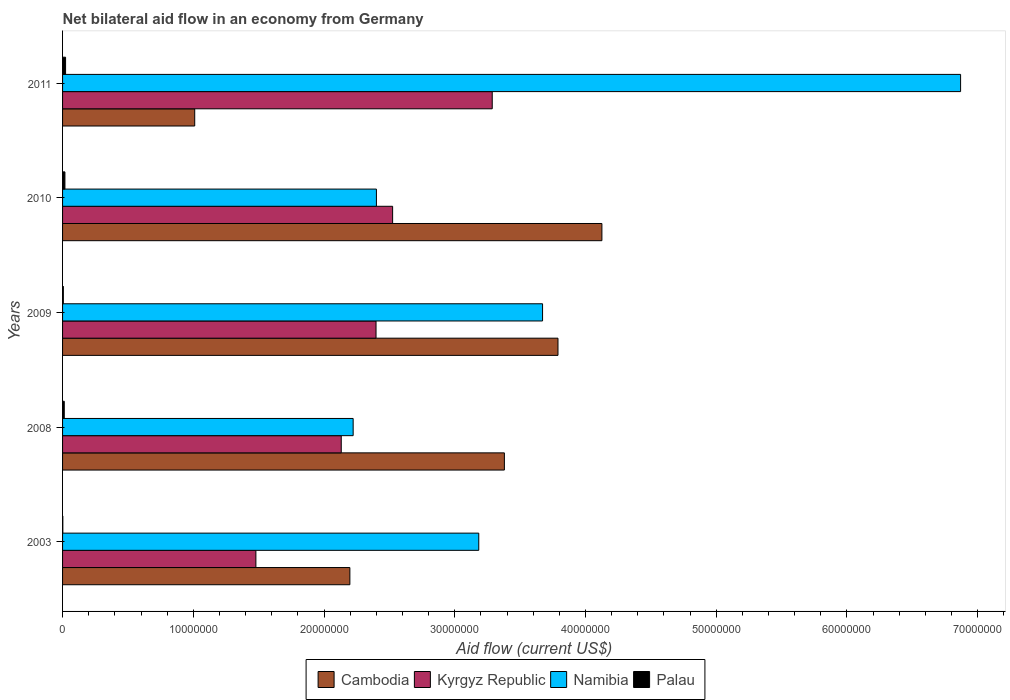How many different coloured bars are there?
Your answer should be compact. 4. How many groups of bars are there?
Offer a terse response. 5. Are the number of bars on each tick of the Y-axis equal?
Provide a short and direct response. Yes. How many bars are there on the 1st tick from the bottom?
Your answer should be very brief. 4. What is the net bilateral aid flow in Namibia in 2008?
Offer a terse response. 2.22e+07. Across all years, what is the maximum net bilateral aid flow in Namibia?
Give a very brief answer. 6.87e+07. Across all years, what is the minimum net bilateral aid flow in Kyrgyz Republic?
Offer a very short reply. 1.48e+07. In which year was the net bilateral aid flow in Kyrgyz Republic maximum?
Keep it short and to the point. 2011. In which year was the net bilateral aid flow in Palau minimum?
Provide a succinct answer. 2003. What is the total net bilateral aid flow in Kyrgyz Republic in the graph?
Give a very brief answer. 1.18e+08. What is the difference between the net bilateral aid flow in Palau in 2008 and that in 2011?
Offer a very short reply. -1.00e+05. What is the difference between the net bilateral aid flow in Kyrgyz Republic in 2010 and the net bilateral aid flow in Cambodia in 2003?
Your answer should be very brief. 3.27e+06. What is the average net bilateral aid flow in Namibia per year?
Provide a short and direct response. 3.67e+07. In the year 2009, what is the difference between the net bilateral aid flow in Namibia and net bilateral aid flow in Kyrgyz Republic?
Ensure brevity in your answer.  1.27e+07. In how many years, is the net bilateral aid flow in Cambodia greater than 40000000 US$?
Your answer should be compact. 1. What is the ratio of the net bilateral aid flow in Palau in 2003 to that in 2009?
Your answer should be compact. 0.33. What is the difference between the highest and the second highest net bilateral aid flow in Kyrgyz Republic?
Offer a terse response. 7.62e+06. What is the difference between the highest and the lowest net bilateral aid flow in Cambodia?
Give a very brief answer. 3.12e+07. In how many years, is the net bilateral aid flow in Kyrgyz Republic greater than the average net bilateral aid flow in Kyrgyz Republic taken over all years?
Your response must be concise. 3. Is the sum of the net bilateral aid flow in Namibia in 2009 and 2010 greater than the maximum net bilateral aid flow in Kyrgyz Republic across all years?
Ensure brevity in your answer.  Yes. Is it the case that in every year, the sum of the net bilateral aid flow in Cambodia and net bilateral aid flow in Palau is greater than the sum of net bilateral aid flow in Namibia and net bilateral aid flow in Kyrgyz Republic?
Provide a short and direct response. No. What does the 1st bar from the top in 2009 represents?
Your answer should be compact. Palau. What does the 3rd bar from the bottom in 2003 represents?
Provide a succinct answer. Namibia. Are all the bars in the graph horizontal?
Keep it short and to the point. Yes. How many years are there in the graph?
Provide a succinct answer. 5. What is the difference between two consecutive major ticks on the X-axis?
Your response must be concise. 1.00e+07. Are the values on the major ticks of X-axis written in scientific E-notation?
Ensure brevity in your answer.  No. Does the graph contain any zero values?
Offer a very short reply. No. Does the graph contain grids?
Give a very brief answer. No. Where does the legend appear in the graph?
Provide a short and direct response. Bottom center. What is the title of the graph?
Your answer should be compact. Net bilateral aid flow in an economy from Germany. What is the label or title of the Y-axis?
Your response must be concise. Years. What is the Aid flow (current US$) of Cambodia in 2003?
Keep it short and to the point. 2.20e+07. What is the Aid flow (current US$) of Kyrgyz Republic in 2003?
Keep it short and to the point. 1.48e+07. What is the Aid flow (current US$) of Namibia in 2003?
Make the answer very short. 3.18e+07. What is the Aid flow (current US$) of Cambodia in 2008?
Give a very brief answer. 3.38e+07. What is the Aid flow (current US$) in Kyrgyz Republic in 2008?
Your answer should be compact. 2.13e+07. What is the Aid flow (current US$) in Namibia in 2008?
Ensure brevity in your answer.  2.22e+07. What is the Aid flow (current US$) in Palau in 2008?
Your answer should be very brief. 1.30e+05. What is the Aid flow (current US$) in Cambodia in 2009?
Your response must be concise. 3.79e+07. What is the Aid flow (current US$) in Kyrgyz Republic in 2009?
Keep it short and to the point. 2.40e+07. What is the Aid flow (current US$) in Namibia in 2009?
Your response must be concise. 3.67e+07. What is the Aid flow (current US$) in Palau in 2009?
Provide a short and direct response. 6.00e+04. What is the Aid flow (current US$) of Cambodia in 2010?
Provide a succinct answer. 4.13e+07. What is the Aid flow (current US$) of Kyrgyz Republic in 2010?
Ensure brevity in your answer.  2.52e+07. What is the Aid flow (current US$) in Namibia in 2010?
Your response must be concise. 2.40e+07. What is the Aid flow (current US$) of Palau in 2010?
Provide a short and direct response. 1.80e+05. What is the Aid flow (current US$) of Cambodia in 2011?
Your answer should be compact. 1.01e+07. What is the Aid flow (current US$) in Kyrgyz Republic in 2011?
Ensure brevity in your answer.  3.29e+07. What is the Aid flow (current US$) of Namibia in 2011?
Your response must be concise. 6.87e+07. Across all years, what is the maximum Aid flow (current US$) in Cambodia?
Your answer should be very brief. 4.13e+07. Across all years, what is the maximum Aid flow (current US$) in Kyrgyz Republic?
Make the answer very short. 3.29e+07. Across all years, what is the maximum Aid flow (current US$) of Namibia?
Keep it short and to the point. 6.87e+07. Across all years, what is the maximum Aid flow (current US$) of Palau?
Make the answer very short. 2.30e+05. Across all years, what is the minimum Aid flow (current US$) of Cambodia?
Keep it short and to the point. 1.01e+07. Across all years, what is the minimum Aid flow (current US$) in Kyrgyz Republic?
Offer a terse response. 1.48e+07. Across all years, what is the minimum Aid flow (current US$) of Namibia?
Offer a terse response. 2.22e+07. What is the total Aid flow (current US$) of Cambodia in the graph?
Give a very brief answer. 1.45e+08. What is the total Aid flow (current US$) of Kyrgyz Republic in the graph?
Ensure brevity in your answer.  1.18e+08. What is the total Aid flow (current US$) in Namibia in the graph?
Provide a succinct answer. 1.84e+08. What is the total Aid flow (current US$) in Palau in the graph?
Provide a short and direct response. 6.20e+05. What is the difference between the Aid flow (current US$) in Cambodia in 2003 and that in 2008?
Give a very brief answer. -1.18e+07. What is the difference between the Aid flow (current US$) in Kyrgyz Republic in 2003 and that in 2008?
Give a very brief answer. -6.53e+06. What is the difference between the Aid flow (current US$) of Namibia in 2003 and that in 2008?
Keep it short and to the point. 9.61e+06. What is the difference between the Aid flow (current US$) in Palau in 2003 and that in 2008?
Provide a succinct answer. -1.10e+05. What is the difference between the Aid flow (current US$) in Cambodia in 2003 and that in 2009?
Ensure brevity in your answer.  -1.59e+07. What is the difference between the Aid flow (current US$) of Kyrgyz Republic in 2003 and that in 2009?
Offer a very short reply. -9.19e+06. What is the difference between the Aid flow (current US$) of Namibia in 2003 and that in 2009?
Provide a succinct answer. -4.88e+06. What is the difference between the Aid flow (current US$) in Cambodia in 2003 and that in 2010?
Give a very brief answer. -1.93e+07. What is the difference between the Aid flow (current US$) of Kyrgyz Republic in 2003 and that in 2010?
Provide a succinct answer. -1.05e+07. What is the difference between the Aid flow (current US$) in Namibia in 2003 and that in 2010?
Your answer should be compact. 7.83e+06. What is the difference between the Aid flow (current US$) of Palau in 2003 and that in 2010?
Keep it short and to the point. -1.60e+05. What is the difference between the Aid flow (current US$) in Cambodia in 2003 and that in 2011?
Your answer should be very brief. 1.19e+07. What is the difference between the Aid flow (current US$) of Kyrgyz Republic in 2003 and that in 2011?
Offer a very short reply. -1.81e+07. What is the difference between the Aid flow (current US$) in Namibia in 2003 and that in 2011?
Keep it short and to the point. -3.69e+07. What is the difference between the Aid flow (current US$) in Cambodia in 2008 and that in 2009?
Offer a terse response. -4.10e+06. What is the difference between the Aid flow (current US$) in Kyrgyz Republic in 2008 and that in 2009?
Your answer should be compact. -2.66e+06. What is the difference between the Aid flow (current US$) in Namibia in 2008 and that in 2009?
Offer a very short reply. -1.45e+07. What is the difference between the Aid flow (current US$) of Palau in 2008 and that in 2009?
Offer a very short reply. 7.00e+04. What is the difference between the Aid flow (current US$) of Cambodia in 2008 and that in 2010?
Your answer should be compact. -7.46e+06. What is the difference between the Aid flow (current US$) in Kyrgyz Republic in 2008 and that in 2010?
Offer a terse response. -3.93e+06. What is the difference between the Aid flow (current US$) of Namibia in 2008 and that in 2010?
Your answer should be compact. -1.78e+06. What is the difference between the Aid flow (current US$) of Palau in 2008 and that in 2010?
Provide a succinct answer. -5.00e+04. What is the difference between the Aid flow (current US$) in Cambodia in 2008 and that in 2011?
Provide a short and direct response. 2.37e+07. What is the difference between the Aid flow (current US$) of Kyrgyz Republic in 2008 and that in 2011?
Your answer should be very brief. -1.16e+07. What is the difference between the Aid flow (current US$) in Namibia in 2008 and that in 2011?
Your answer should be compact. -4.65e+07. What is the difference between the Aid flow (current US$) in Palau in 2008 and that in 2011?
Your response must be concise. -1.00e+05. What is the difference between the Aid flow (current US$) of Cambodia in 2009 and that in 2010?
Provide a succinct answer. -3.36e+06. What is the difference between the Aid flow (current US$) in Kyrgyz Republic in 2009 and that in 2010?
Give a very brief answer. -1.27e+06. What is the difference between the Aid flow (current US$) of Namibia in 2009 and that in 2010?
Offer a very short reply. 1.27e+07. What is the difference between the Aid flow (current US$) of Cambodia in 2009 and that in 2011?
Provide a short and direct response. 2.78e+07. What is the difference between the Aid flow (current US$) of Kyrgyz Republic in 2009 and that in 2011?
Your response must be concise. -8.89e+06. What is the difference between the Aid flow (current US$) of Namibia in 2009 and that in 2011?
Keep it short and to the point. -3.20e+07. What is the difference between the Aid flow (current US$) in Palau in 2009 and that in 2011?
Ensure brevity in your answer.  -1.70e+05. What is the difference between the Aid flow (current US$) of Cambodia in 2010 and that in 2011?
Provide a succinct answer. 3.12e+07. What is the difference between the Aid flow (current US$) of Kyrgyz Republic in 2010 and that in 2011?
Your answer should be compact. -7.62e+06. What is the difference between the Aid flow (current US$) in Namibia in 2010 and that in 2011?
Your response must be concise. -4.47e+07. What is the difference between the Aid flow (current US$) in Cambodia in 2003 and the Aid flow (current US$) in Kyrgyz Republic in 2008?
Make the answer very short. 6.60e+05. What is the difference between the Aid flow (current US$) of Cambodia in 2003 and the Aid flow (current US$) of Palau in 2008?
Make the answer very short. 2.18e+07. What is the difference between the Aid flow (current US$) in Kyrgyz Republic in 2003 and the Aid flow (current US$) in Namibia in 2008?
Provide a short and direct response. -7.44e+06. What is the difference between the Aid flow (current US$) of Kyrgyz Republic in 2003 and the Aid flow (current US$) of Palau in 2008?
Provide a succinct answer. 1.47e+07. What is the difference between the Aid flow (current US$) of Namibia in 2003 and the Aid flow (current US$) of Palau in 2008?
Ensure brevity in your answer.  3.17e+07. What is the difference between the Aid flow (current US$) in Cambodia in 2003 and the Aid flow (current US$) in Namibia in 2009?
Offer a terse response. -1.47e+07. What is the difference between the Aid flow (current US$) in Cambodia in 2003 and the Aid flow (current US$) in Palau in 2009?
Ensure brevity in your answer.  2.19e+07. What is the difference between the Aid flow (current US$) in Kyrgyz Republic in 2003 and the Aid flow (current US$) in Namibia in 2009?
Provide a short and direct response. -2.19e+07. What is the difference between the Aid flow (current US$) in Kyrgyz Republic in 2003 and the Aid flow (current US$) in Palau in 2009?
Provide a succinct answer. 1.47e+07. What is the difference between the Aid flow (current US$) of Namibia in 2003 and the Aid flow (current US$) of Palau in 2009?
Your response must be concise. 3.18e+07. What is the difference between the Aid flow (current US$) of Cambodia in 2003 and the Aid flow (current US$) of Kyrgyz Republic in 2010?
Offer a terse response. -3.27e+06. What is the difference between the Aid flow (current US$) in Cambodia in 2003 and the Aid flow (current US$) in Namibia in 2010?
Offer a very short reply. -2.03e+06. What is the difference between the Aid flow (current US$) of Cambodia in 2003 and the Aid flow (current US$) of Palau in 2010?
Make the answer very short. 2.18e+07. What is the difference between the Aid flow (current US$) of Kyrgyz Republic in 2003 and the Aid flow (current US$) of Namibia in 2010?
Ensure brevity in your answer.  -9.22e+06. What is the difference between the Aid flow (current US$) in Kyrgyz Republic in 2003 and the Aid flow (current US$) in Palau in 2010?
Keep it short and to the point. 1.46e+07. What is the difference between the Aid flow (current US$) of Namibia in 2003 and the Aid flow (current US$) of Palau in 2010?
Offer a very short reply. 3.17e+07. What is the difference between the Aid flow (current US$) in Cambodia in 2003 and the Aid flow (current US$) in Kyrgyz Republic in 2011?
Ensure brevity in your answer.  -1.09e+07. What is the difference between the Aid flow (current US$) in Cambodia in 2003 and the Aid flow (current US$) in Namibia in 2011?
Keep it short and to the point. -4.67e+07. What is the difference between the Aid flow (current US$) of Cambodia in 2003 and the Aid flow (current US$) of Palau in 2011?
Make the answer very short. 2.18e+07. What is the difference between the Aid flow (current US$) of Kyrgyz Republic in 2003 and the Aid flow (current US$) of Namibia in 2011?
Keep it short and to the point. -5.39e+07. What is the difference between the Aid flow (current US$) in Kyrgyz Republic in 2003 and the Aid flow (current US$) in Palau in 2011?
Offer a very short reply. 1.46e+07. What is the difference between the Aid flow (current US$) of Namibia in 2003 and the Aid flow (current US$) of Palau in 2011?
Your answer should be compact. 3.16e+07. What is the difference between the Aid flow (current US$) of Cambodia in 2008 and the Aid flow (current US$) of Kyrgyz Republic in 2009?
Provide a succinct answer. 9.82e+06. What is the difference between the Aid flow (current US$) in Cambodia in 2008 and the Aid flow (current US$) in Namibia in 2009?
Offer a terse response. -2.92e+06. What is the difference between the Aid flow (current US$) of Cambodia in 2008 and the Aid flow (current US$) of Palau in 2009?
Give a very brief answer. 3.37e+07. What is the difference between the Aid flow (current US$) in Kyrgyz Republic in 2008 and the Aid flow (current US$) in Namibia in 2009?
Offer a very short reply. -1.54e+07. What is the difference between the Aid flow (current US$) of Kyrgyz Republic in 2008 and the Aid flow (current US$) of Palau in 2009?
Your answer should be compact. 2.13e+07. What is the difference between the Aid flow (current US$) in Namibia in 2008 and the Aid flow (current US$) in Palau in 2009?
Provide a succinct answer. 2.22e+07. What is the difference between the Aid flow (current US$) in Cambodia in 2008 and the Aid flow (current US$) in Kyrgyz Republic in 2010?
Provide a short and direct response. 8.55e+06. What is the difference between the Aid flow (current US$) of Cambodia in 2008 and the Aid flow (current US$) of Namibia in 2010?
Your response must be concise. 9.79e+06. What is the difference between the Aid flow (current US$) of Cambodia in 2008 and the Aid flow (current US$) of Palau in 2010?
Make the answer very short. 3.36e+07. What is the difference between the Aid flow (current US$) of Kyrgyz Republic in 2008 and the Aid flow (current US$) of Namibia in 2010?
Make the answer very short. -2.69e+06. What is the difference between the Aid flow (current US$) of Kyrgyz Republic in 2008 and the Aid flow (current US$) of Palau in 2010?
Provide a succinct answer. 2.11e+07. What is the difference between the Aid flow (current US$) of Namibia in 2008 and the Aid flow (current US$) of Palau in 2010?
Make the answer very short. 2.20e+07. What is the difference between the Aid flow (current US$) in Cambodia in 2008 and the Aid flow (current US$) in Kyrgyz Republic in 2011?
Give a very brief answer. 9.30e+05. What is the difference between the Aid flow (current US$) of Cambodia in 2008 and the Aid flow (current US$) of Namibia in 2011?
Your response must be concise. -3.49e+07. What is the difference between the Aid flow (current US$) of Cambodia in 2008 and the Aid flow (current US$) of Palau in 2011?
Make the answer very short. 3.36e+07. What is the difference between the Aid flow (current US$) in Kyrgyz Republic in 2008 and the Aid flow (current US$) in Namibia in 2011?
Provide a succinct answer. -4.74e+07. What is the difference between the Aid flow (current US$) of Kyrgyz Republic in 2008 and the Aid flow (current US$) of Palau in 2011?
Your response must be concise. 2.11e+07. What is the difference between the Aid flow (current US$) of Namibia in 2008 and the Aid flow (current US$) of Palau in 2011?
Keep it short and to the point. 2.20e+07. What is the difference between the Aid flow (current US$) in Cambodia in 2009 and the Aid flow (current US$) in Kyrgyz Republic in 2010?
Provide a short and direct response. 1.26e+07. What is the difference between the Aid flow (current US$) of Cambodia in 2009 and the Aid flow (current US$) of Namibia in 2010?
Give a very brief answer. 1.39e+07. What is the difference between the Aid flow (current US$) of Cambodia in 2009 and the Aid flow (current US$) of Palau in 2010?
Provide a short and direct response. 3.77e+07. What is the difference between the Aid flow (current US$) of Kyrgyz Republic in 2009 and the Aid flow (current US$) of Namibia in 2010?
Ensure brevity in your answer.  -3.00e+04. What is the difference between the Aid flow (current US$) of Kyrgyz Republic in 2009 and the Aid flow (current US$) of Palau in 2010?
Give a very brief answer. 2.38e+07. What is the difference between the Aid flow (current US$) in Namibia in 2009 and the Aid flow (current US$) in Palau in 2010?
Provide a short and direct response. 3.65e+07. What is the difference between the Aid flow (current US$) in Cambodia in 2009 and the Aid flow (current US$) in Kyrgyz Republic in 2011?
Your response must be concise. 5.03e+06. What is the difference between the Aid flow (current US$) of Cambodia in 2009 and the Aid flow (current US$) of Namibia in 2011?
Give a very brief answer. -3.08e+07. What is the difference between the Aid flow (current US$) of Cambodia in 2009 and the Aid flow (current US$) of Palau in 2011?
Your answer should be compact. 3.77e+07. What is the difference between the Aid flow (current US$) of Kyrgyz Republic in 2009 and the Aid flow (current US$) of Namibia in 2011?
Ensure brevity in your answer.  -4.47e+07. What is the difference between the Aid flow (current US$) in Kyrgyz Republic in 2009 and the Aid flow (current US$) in Palau in 2011?
Offer a very short reply. 2.38e+07. What is the difference between the Aid flow (current US$) of Namibia in 2009 and the Aid flow (current US$) of Palau in 2011?
Provide a short and direct response. 3.65e+07. What is the difference between the Aid flow (current US$) of Cambodia in 2010 and the Aid flow (current US$) of Kyrgyz Republic in 2011?
Provide a succinct answer. 8.39e+06. What is the difference between the Aid flow (current US$) of Cambodia in 2010 and the Aid flow (current US$) of Namibia in 2011?
Give a very brief answer. -2.74e+07. What is the difference between the Aid flow (current US$) of Cambodia in 2010 and the Aid flow (current US$) of Palau in 2011?
Your response must be concise. 4.10e+07. What is the difference between the Aid flow (current US$) in Kyrgyz Republic in 2010 and the Aid flow (current US$) in Namibia in 2011?
Your answer should be compact. -4.34e+07. What is the difference between the Aid flow (current US$) in Kyrgyz Republic in 2010 and the Aid flow (current US$) in Palau in 2011?
Provide a succinct answer. 2.50e+07. What is the difference between the Aid flow (current US$) in Namibia in 2010 and the Aid flow (current US$) in Palau in 2011?
Provide a short and direct response. 2.38e+07. What is the average Aid flow (current US$) of Cambodia per year?
Your response must be concise. 2.90e+07. What is the average Aid flow (current US$) of Kyrgyz Republic per year?
Provide a short and direct response. 2.36e+07. What is the average Aid flow (current US$) of Namibia per year?
Ensure brevity in your answer.  3.67e+07. What is the average Aid flow (current US$) in Palau per year?
Keep it short and to the point. 1.24e+05. In the year 2003, what is the difference between the Aid flow (current US$) in Cambodia and Aid flow (current US$) in Kyrgyz Republic?
Provide a succinct answer. 7.19e+06. In the year 2003, what is the difference between the Aid flow (current US$) of Cambodia and Aid flow (current US$) of Namibia?
Make the answer very short. -9.86e+06. In the year 2003, what is the difference between the Aid flow (current US$) in Cambodia and Aid flow (current US$) in Palau?
Make the answer very short. 2.20e+07. In the year 2003, what is the difference between the Aid flow (current US$) in Kyrgyz Republic and Aid flow (current US$) in Namibia?
Offer a very short reply. -1.70e+07. In the year 2003, what is the difference between the Aid flow (current US$) of Kyrgyz Republic and Aid flow (current US$) of Palau?
Your response must be concise. 1.48e+07. In the year 2003, what is the difference between the Aid flow (current US$) in Namibia and Aid flow (current US$) in Palau?
Ensure brevity in your answer.  3.18e+07. In the year 2008, what is the difference between the Aid flow (current US$) of Cambodia and Aid flow (current US$) of Kyrgyz Republic?
Keep it short and to the point. 1.25e+07. In the year 2008, what is the difference between the Aid flow (current US$) in Cambodia and Aid flow (current US$) in Namibia?
Provide a short and direct response. 1.16e+07. In the year 2008, what is the difference between the Aid flow (current US$) in Cambodia and Aid flow (current US$) in Palau?
Provide a short and direct response. 3.37e+07. In the year 2008, what is the difference between the Aid flow (current US$) in Kyrgyz Republic and Aid flow (current US$) in Namibia?
Provide a succinct answer. -9.10e+05. In the year 2008, what is the difference between the Aid flow (current US$) of Kyrgyz Republic and Aid flow (current US$) of Palau?
Offer a terse response. 2.12e+07. In the year 2008, what is the difference between the Aid flow (current US$) of Namibia and Aid flow (current US$) of Palau?
Give a very brief answer. 2.21e+07. In the year 2009, what is the difference between the Aid flow (current US$) of Cambodia and Aid flow (current US$) of Kyrgyz Republic?
Ensure brevity in your answer.  1.39e+07. In the year 2009, what is the difference between the Aid flow (current US$) in Cambodia and Aid flow (current US$) in Namibia?
Give a very brief answer. 1.18e+06. In the year 2009, what is the difference between the Aid flow (current US$) of Cambodia and Aid flow (current US$) of Palau?
Ensure brevity in your answer.  3.78e+07. In the year 2009, what is the difference between the Aid flow (current US$) in Kyrgyz Republic and Aid flow (current US$) in Namibia?
Your answer should be compact. -1.27e+07. In the year 2009, what is the difference between the Aid flow (current US$) in Kyrgyz Republic and Aid flow (current US$) in Palau?
Offer a very short reply. 2.39e+07. In the year 2009, what is the difference between the Aid flow (current US$) of Namibia and Aid flow (current US$) of Palau?
Ensure brevity in your answer.  3.67e+07. In the year 2010, what is the difference between the Aid flow (current US$) of Cambodia and Aid flow (current US$) of Kyrgyz Republic?
Offer a terse response. 1.60e+07. In the year 2010, what is the difference between the Aid flow (current US$) of Cambodia and Aid flow (current US$) of Namibia?
Make the answer very short. 1.72e+07. In the year 2010, what is the difference between the Aid flow (current US$) of Cambodia and Aid flow (current US$) of Palau?
Ensure brevity in your answer.  4.11e+07. In the year 2010, what is the difference between the Aid flow (current US$) of Kyrgyz Republic and Aid flow (current US$) of Namibia?
Your answer should be compact. 1.24e+06. In the year 2010, what is the difference between the Aid flow (current US$) of Kyrgyz Republic and Aid flow (current US$) of Palau?
Your answer should be very brief. 2.51e+07. In the year 2010, what is the difference between the Aid flow (current US$) of Namibia and Aid flow (current US$) of Palau?
Your answer should be compact. 2.38e+07. In the year 2011, what is the difference between the Aid flow (current US$) in Cambodia and Aid flow (current US$) in Kyrgyz Republic?
Your answer should be very brief. -2.28e+07. In the year 2011, what is the difference between the Aid flow (current US$) of Cambodia and Aid flow (current US$) of Namibia?
Offer a terse response. -5.86e+07. In the year 2011, what is the difference between the Aid flow (current US$) in Cambodia and Aid flow (current US$) in Palau?
Your answer should be very brief. 9.88e+06. In the year 2011, what is the difference between the Aid flow (current US$) in Kyrgyz Republic and Aid flow (current US$) in Namibia?
Offer a very short reply. -3.58e+07. In the year 2011, what is the difference between the Aid flow (current US$) of Kyrgyz Republic and Aid flow (current US$) of Palau?
Your answer should be very brief. 3.26e+07. In the year 2011, what is the difference between the Aid flow (current US$) in Namibia and Aid flow (current US$) in Palau?
Keep it short and to the point. 6.85e+07. What is the ratio of the Aid flow (current US$) of Cambodia in 2003 to that in 2008?
Keep it short and to the point. 0.65. What is the ratio of the Aid flow (current US$) in Kyrgyz Republic in 2003 to that in 2008?
Ensure brevity in your answer.  0.69. What is the ratio of the Aid flow (current US$) of Namibia in 2003 to that in 2008?
Ensure brevity in your answer.  1.43. What is the ratio of the Aid flow (current US$) in Palau in 2003 to that in 2008?
Your answer should be compact. 0.15. What is the ratio of the Aid flow (current US$) in Cambodia in 2003 to that in 2009?
Provide a succinct answer. 0.58. What is the ratio of the Aid flow (current US$) of Kyrgyz Republic in 2003 to that in 2009?
Offer a very short reply. 0.62. What is the ratio of the Aid flow (current US$) in Namibia in 2003 to that in 2009?
Ensure brevity in your answer.  0.87. What is the ratio of the Aid flow (current US$) of Palau in 2003 to that in 2009?
Your answer should be very brief. 0.33. What is the ratio of the Aid flow (current US$) of Cambodia in 2003 to that in 2010?
Keep it short and to the point. 0.53. What is the ratio of the Aid flow (current US$) in Kyrgyz Republic in 2003 to that in 2010?
Provide a short and direct response. 0.59. What is the ratio of the Aid flow (current US$) of Namibia in 2003 to that in 2010?
Give a very brief answer. 1.33. What is the ratio of the Aid flow (current US$) of Palau in 2003 to that in 2010?
Make the answer very short. 0.11. What is the ratio of the Aid flow (current US$) of Cambodia in 2003 to that in 2011?
Offer a terse response. 2.17. What is the ratio of the Aid flow (current US$) in Kyrgyz Republic in 2003 to that in 2011?
Ensure brevity in your answer.  0.45. What is the ratio of the Aid flow (current US$) in Namibia in 2003 to that in 2011?
Ensure brevity in your answer.  0.46. What is the ratio of the Aid flow (current US$) of Palau in 2003 to that in 2011?
Provide a short and direct response. 0.09. What is the ratio of the Aid flow (current US$) in Cambodia in 2008 to that in 2009?
Provide a succinct answer. 0.89. What is the ratio of the Aid flow (current US$) in Kyrgyz Republic in 2008 to that in 2009?
Your response must be concise. 0.89. What is the ratio of the Aid flow (current US$) of Namibia in 2008 to that in 2009?
Your answer should be compact. 0.61. What is the ratio of the Aid flow (current US$) in Palau in 2008 to that in 2009?
Offer a terse response. 2.17. What is the ratio of the Aid flow (current US$) of Cambodia in 2008 to that in 2010?
Your response must be concise. 0.82. What is the ratio of the Aid flow (current US$) in Kyrgyz Republic in 2008 to that in 2010?
Offer a very short reply. 0.84. What is the ratio of the Aid flow (current US$) in Namibia in 2008 to that in 2010?
Give a very brief answer. 0.93. What is the ratio of the Aid flow (current US$) in Palau in 2008 to that in 2010?
Provide a short and direct response. 0.72. What is the ratio of the Aid flow (current US$) of Cambodia in 2008 to that in 2011?
Offer a terse response. 3.34. What is the ratio of the Aid flow (current US$) of Kyrgyz Republic in 2008 to that in 2011?
Your answer should be very brief. 0.65. What is the ratio of the Aid flow (current US$) in Namibia in 2008 to that in 2011?
Make the answer very short. 0.32. What is the ratio of the Aid flow (current US$) of Palau in 2008 to that in 2011?
Your response must be concise. 0.57. What is the ratio of the Aid flow (current US$) in Cambodia in 2009 to that in 2010?
Offer a very short reply. 0.92. What is the ratio of the Aid flow (current US$) in Kyrgyz Republic in 2009 to that in 2010?
Offer a very short reply. 0.95. What is the ratio of the Aid flow (current US$) of Namibia in 2009 to that in 2010?
Offer a very short reply. 1.53. What is the ratio of the Aid flow (current US$) of Palau in 2009 to that in 2010?
Offer a terse response. 0.33. What is the ratio of the Aid flow (current US$) of Cambodia in 2009 to that in 2011?
Provide a succinct answer. 3.75. What is the ratio of the Aid flow (current US$) in Kyrgyz Republic in 2009 to that in 2011?
Provide a short and direct response. 0.73. What is the ratio of the Aid flow (current US$) in Namibia in 2009 to that in 2011?
Make the answer very short. 0.53. What is the ratio of the Aid flow (current US$) of Palau in 2009 to that in 2011?
Your response must be concise. 0.26. What is the ratio of the Aid flow (current US$) in Cambodia in 2010 to that in 2011?
Your response must be concise. 4.08. What is the ratio of the Aid flow (current US$) in Kyrgyz Republic in 2010 to that in 2011?
Give a very brief answer. 0.77. What is the ratio of the Aid flow (current US$) in Namibia in 2010 to that in 2011?
Make the answer very short. 0.35. What is the ratio of the Aid flow (current US$) of Palau in 2010 to that in 2011?
Your answer should be compact. 0.78. What is the difference between the highest and the second highest Aid flow (current US$) of Cambodia?
Provide a short and direct response. 3.36e+06. What is the difference between the highest and the second highest Aid flow (current US$) in Kyrgyz Republic?
Offer a terse response. 7.62e+06. What is the difference between the highest and the second highest Aid flow (current US$) in Namibia?
Provide a short and direct response. 3.20e+07. What is the difference between the highest and the lowest Aid flow (current US$) of Cambodia?
Keep it short and to the point. 3.12e+07. What is the difference between the highest and the lowest Aid flow (current US$) of Kyrgyz Republic?
Your answer should be compact. 1.81e+07. What is the difference between the highest and the lowest Aid flow (current US$) of Namibia?
Provide a short and direct response. 4.65e+07. 